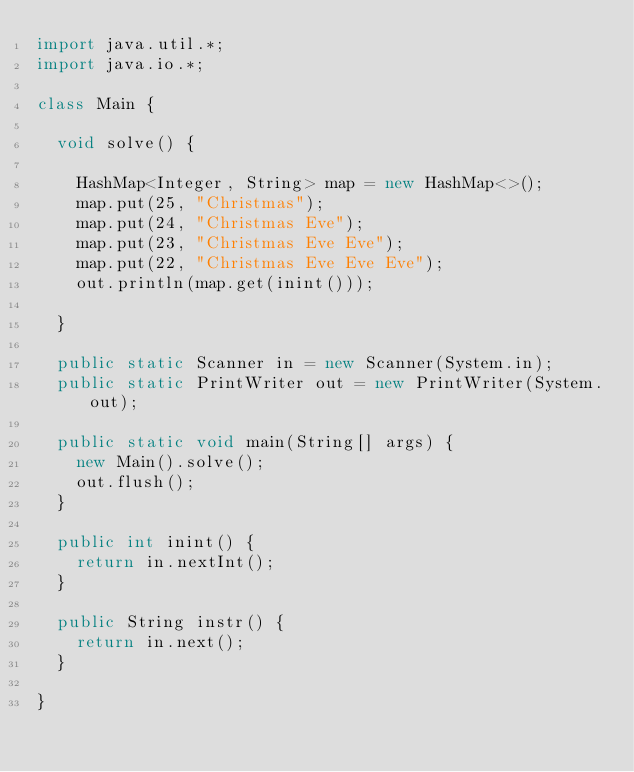Convert code to text. <code><loc_0><loc_0><loc_500><loc_500><_Java_>import java.util.*;
import java.io.*;

class Main {

	void solve() {

		HashMap<Integer, String> map = new HashMap<>();
		map.put(25, "Christmas");
		map.put(24, "Christmas Eve");
		map.put(23, "Christmas Eve Eve");
		map.put(22, "Christmas Eve Eve Eve");
		out.println(map.get(inint()));
		
	}
	
	public static Scanner in = new Scanner(System.in);
	public static PrintWriter out = new PrintWriter(System.out);
	
	public static void main(String[] args) {
		new Main().solve();
		out.flush();
	}
	
	public int inint() {
		return in.nextInt();
	}
	
	public String instr() {
		return in.next();
	}

}</code> 